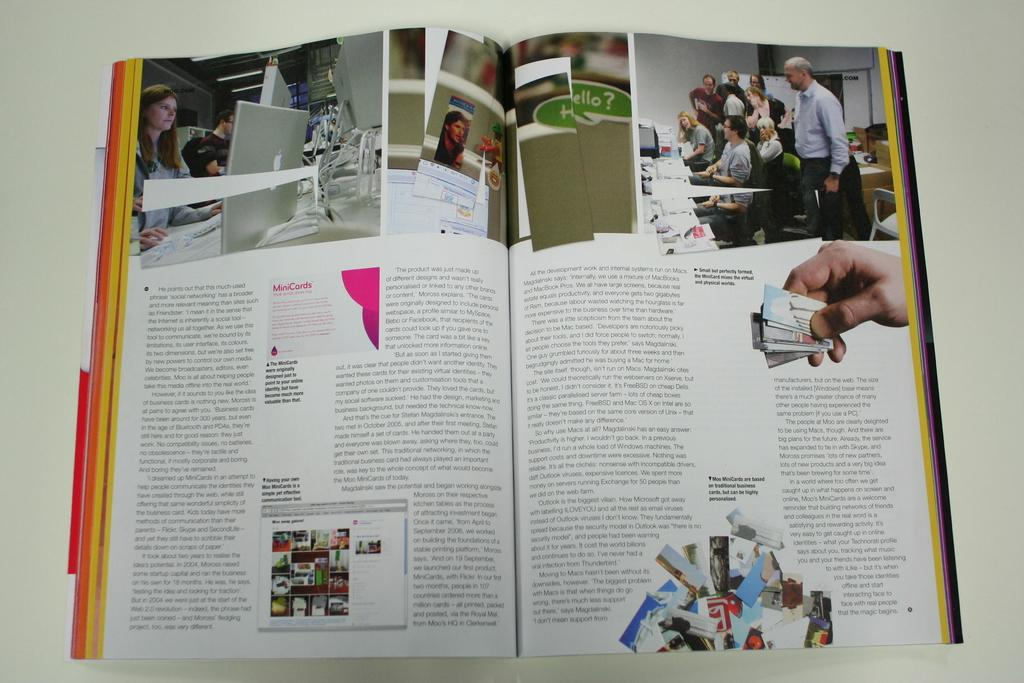<image>
Provide a brief description of the given image. an opened book with the word MiniCards on it 